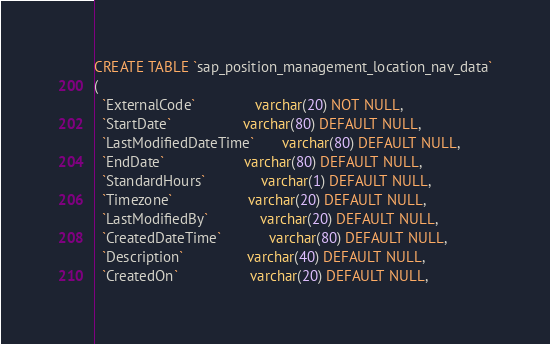<code> <loc_0><loc_0><loc_500><loc_500><_SQL_>CREATE TABLE `sap_position_management_location_nav_data`
(
  `ExternalCode`               varchar(20) NOT NULL,
  `StartDate`                  varchar(80) DEFAULT NULL,
  `LastModifiedDateTime`       varchar(80) DEFAULT NULL,
  `EndDate`                    varchar(80) DEFAULT NULL,
  `StandardHours`              varchar(1) DEFAULT NULL,
  `Timezone`                   varchar(20) DEFAULT NULL,
  `LastModifiedBy`             varchar(20) DEFAULT NULL,
  `CreatedDateTime`            varchar(80) DEFAULT NULL,
  `Description`                varchar(40) DEFAULT NULL,
  `CreatedOn`                  varchar(20) DEFAULT NULL,</code> 